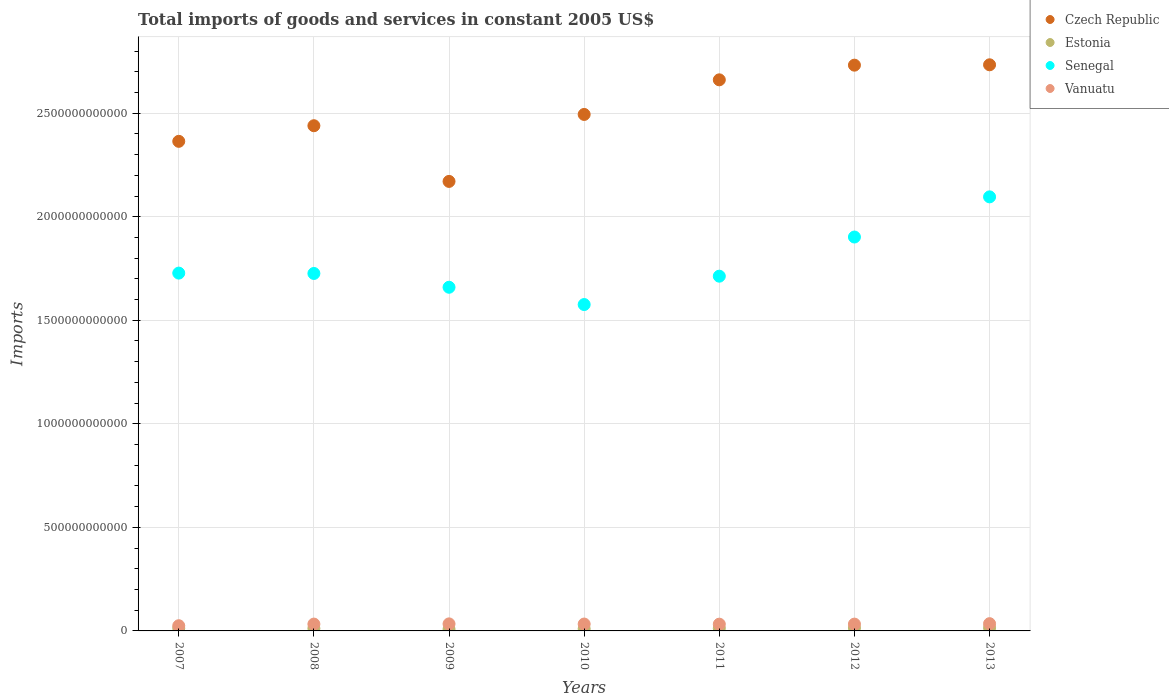How many different coloured dotlines are there?
Your answer should be very brief. 4. Is the number of dotlines equal to the number of legend labels?
Offer a terse response. Yes. What is the total imports of goods and services in Estonia in 2007?
Provide a succinct answer. 1.28e+1. Across all years, what is the maximum total imports of goods and services in Vanuatu?
Your answer should be compact. 3.50e+1. Across all years, what is the minimum total imports of goods and services in Czech Republic?
Keep it short and to the point. 2.17e+12. In which year was the total imports of goods and services in Czech Republic maximum?
Your answer should be very brief. 2013. What is the total total imports of goods and services in Vanuatu in the graph?
Your answer should be very brief. 2.26e+11. What is the difference between the total imports of goods and services in Estonia in 2012 and that in 2013?
Offer a terse response. -6.45e+08. What is the difference between the total imports of goods and services in Vanuatu in 2011 and the total imports of goods and services in Estonia in 2012?
Your answer should be very brief. 1.83e+1. What is the average total imports of goods and services in Czech Republic per year?
Provide a succinct answer. 2.51e+12. In the year 2012, what is the difference between the total imports of goods and services in Senegal and total imports of goods and services in Czech Republic?
Your response must be concise. -8.30e+11. In how many years, is the total imports of goods and services in Czech Republic greater than 100000000000 US$?
Give a very brief answer. 7. What is the ratio of the total imports of goods and services in Estonia in 2007 to that in 2010?
Offer a very short reply. 1.27. Is the total imports of goods and services in Czech Republic in 2007 less than that in 2009?
Your answer should be very brief. No. Is the difference between the total imports of goods and services in Senegal in 2009 and 2013 greater than the difference between the total imports of goods and services in Czech Republic in 2009 and 2013?
Ensure brevity in your answer.  Yes. What is the difference between the highest and the second highest total imports of goods and services in Senegal?
Keep it short and to the point. 1.94e+11. What is the difference between the highest and the lowest total imports of goods and services in Estonia?
Your answer should be compact. 6.67e+09. In how many years, is the total imports of goods and services in Senegal greater than the average total imports of goods and services in Senegal taken over all years?
Offer a terse response. 2. Is it the case that in every year, the sum of the total imports of goods and services in Czech Republic and total imports of goods and services in Senegal  is greater than the total imports of goods and services in Estonia?
Give a very brief answer. Yes. Does the total imports of goods and services in Estonia monotonically increase over the years?
Make the answer very short. No. How many dotlines are there?
Your answer should be compact. 4. How many years are there in the graph?
Give a very brief answer. 7. What is the difference between two consecutive major ticks on the Y-axis?
Provide a succinct answer. 5.00e+11. Does the graph contain any zero values?
Provide a short and direct response. No. Does the graph contain grids?
Provide a short and direct response. Yes. How many legend labels are there?
Provide a short and direct response. 4. What is the title of the graph?
Your response must be concise. Total imports of goods and services in constant 2005 US$. What is the label or title of the X-axis?
Your answer should be compact. Years. What is the label or title of the Y-axis?
Offer a terse response. Imports. What is the Imports of Czech Republic in 2007?
Offer a terse response. 2.36e+12. What is the Imports in Estonia in 2007?
Give a very brief answer. 1.28e+1. What is the Imports in Senegal in 2007?
Provide a succinct answer. 1.73e+12. What is the Imports of Vanuatu in 2007?
Offer a terse response. 2.51e+1. What is the Imports in Czech Republic in 2008?
Your response must be concise. 2.44e+12. What is the Imports in Estonia in 2008?
Ensure brevity in your answer.  1.20e+1. What is the Imports in Senegal in 2008?
Provide a succinct answer. 1.73e+12. What is the Imports in Vanuatu in 2008?
Provide a succinct answer. 3.30e+1. What is the Imports in Czech Republic in 2009?
Offer a very short reply. 2.17e+12. What is the Imports of Estonia in 2009?
Your answer should be very brief. 8.34e+09. What is the Imports of Senegal in 2009?
Give a very brief answer. 1.66e+12. What is the Imports of Vanuatu in 2009?
Your answer should be compact. 3.40e+1. What is the Imports of Czech Republic in 2010?
Give a very brief answer. 2.49e+12. What is the Imports of Estonia in 2010?
Provide a succinct answer. 1.01e+1. What is the Imports of Senegal in 2010?
Give a very brief answer. 1.58e+12. What is the Imports in Vanuatu in 2010?
Make the answer very short. 3.33e+1. What is the Imports in Czech Republic in 2011?
Provide a succinct answer. 2.66e+12. What is the Imports in Estonia in 2011?
Offer a very short reply. 1.29e+1. What is the Imports of Senegal in 2011?
Your answer should be very brief. 1.71e+12. What is the Imports of Vanuatu in 2011?
Provide a short and direct response. 3.26e+1. What is the Imports of Czech Republic in 2012?
Ensure brevity in your answer.  2.73e+12. What is the Imports of Estonia in 2012?
Give a very brief answer. 1.44e+1. What is the Imports in Senegal in 2012?
Keep it short and to the point. 1.90e+12. What is the Imports in Vanuatu in 2012?
Your answer should be compact. 3.29e+1. What is the Imports in Czech Republic in 2013?
Give a very brief answer. 2.73e+12. What is the Imports of Estonia in 2013?
Keep it short and to the point. 1.50e+1. What is the Imports in Senegal in 2013?
Make the answer very short. 2.10e+12. What is the Imports in Vanuatu in 2013?
Offer a terse response. 3.50e+1. Across all years, what is the maximum Imports of Czech Republic?
Give a very brief answer. 2.73e+12. Across all years, what is the maximum Imports of Estonia?
Give a very brief answer. 1.50e+1. Across all years, what is the maximum Imports of Senegal?
Offer a terse response. 2.10e+12. Across all years, what is the maximum Imports of Vanuatu?
Your response must be concise. 3.50e+1. Across all years, what is the minimum Imports in Czech Republic?
Provide a succinct answer. 2.17e+12. Across all years, what is the minimum Imports of Estonia?
Offer a very short reply. 8.34e+09. Across all years, what is the minimum Imports in Senegal?
Ensure brevity in your answer.  1.58e+12. Across all years, what is the minimum Imports of Vanuatu?
Provide a succinct answer. 2.51e+1. What is the total Imports of Czech Republic in the graph?
Your answer should be compact. 1.76e+13. What is the total Imports in Estonia in the graph?
Provide a succinct answer. 8.55e+1. What is the total Imports in Senegal in the graph?
Your answer should be compact. 1.24e+13. What is the total Imports of Vanuatu in the graph?
Your answer should be very brief. 2.26e+11. What is the difference between the Imports in Czech Republic in 2007 and that in 2008?
Give a very brief answer. -7.54e+1. What is the difference between the Imports of Estonia in 2007 and that in 2008?
Give a very brief answer. 7.89e+08. What is the difference between the Imports in Senegal in 2007 and that in 2008?
Offer a terse response. 1.72e+09. What is the difference between the Imports of Vanuatu in 2007 and that in 2008?
Your response must be concise. -7.90e+09. What is the difference between the Imports in Czech Republic in 2007 and that in 2009?
Provide a succinct answer. 1.94e+11. What is the difference between the Imports of Estonia in 2007 and that in 2009?
Your response must be concise. 4.47e+09. What is the difference between the Imports in Senegal in 2007 and that in 2009?
Keep it short and to the point. 6.83e+1. What is the difference between the Imports of Vanuatu in 2007 and that in 2009?
Provide a succinct answer. -8.87e+09. What is the difference between the Imports in Czech Republic in 2007 and that in 2010?
Your answer should be very brief. -1.30e+11. What is the difference between the Imports of Estonia in 2007 and that in 2010?
Offer a terse response. 2.70e+09. What is the difference between the Imports of Senegal in 2007 and that in 2010?
Offer a terse response. 1.52e+11. What is the difference between the Imports of Vanuatu in 2007 and that in 2010?
Offer a very short reply. -8.14e+09. What is the difference between the Imports of Czech Republic in 2007 and that in 2011?
Keep it short and to the point. -2.97e+11. What is the difference between the Imports in Estonia in 2007 and that in 2011?
Give a very brief answer. -5.48e+07. What is the difference between the Imports in Senegal in 2007 and that in 2011?
Ensure brevity in your answer.  1.49e+1. What is the difference between the Imports in Vanuatu in 2007 and that in 2011?
Provide a short and direct response. -7.50e+09. What is the difference between the Imports of Czech Republic in 2007 and that in 2012?
Your answer should be compact. -3.68e+11. What is the difference between the Imports in Estonia in 2007 and that in 2012?
Give a very brief answer. -1.56e+09. What is the difference between the Imports in Senegal in 2007 and that in 2012?
Offer a very short reply. -1.74e+11. What is the difference between the Imports in Vanuatu in 2007 and that in 2012?
Provide a short and direct response. -7.77e+09. What is the difference between the Imports of Czech Republic in 2007 and that in 2013?
Provide a succinct answer. -3.70e+11. What is the difference between the Imports of Estonia in 2007 and that in 2013?
Offer a very short reply. -2.20e+09. What is the difference between the Imports of Senegal in 2007 and that in 2013?
Make the answer very short. -3.68e+11. What is the difference between the Imports of Vanuatu in 2007 and that in 2013?
Keep it short and to the point. -9.89e+09. What is the difference between the Imports in Czech Republic in 2008 and that in 2009?
Make the answer very short. 2.69e+11. What is the difference between the Imports of Estonia in 2008 and that in 2009?
Provide a succinct answer. 3.68e+09. What is the difference between the Imports in Senegal in 2008 and that in 2009?
Give a very brief answer. 6.66e+1. What is the difference between the Imports of Vanuatu in 2008 and that in 2009?
Your response must be concise. -9.74e+08. What is the difference between the Imports of Czech Republic in 2008 and that in 2010?
Give a very brief answer. -5.45e+1. What is the difference between the Imports of Estonia in 2008 and that in 2010?
Your response must be concise. 1.91e+09. What is the difference between the Imports of Senegal in 2008 and that in 2010?
Give a very brief answer. 1.50e+11. What is the difference between the Imports of Vanuatu in 2008 and that in 2010?
Offer a terse response. -2.38e+08. What is the difference between the Imports of Czech Republic in 2008 and that in 2011?
Make the answer very short. -2.22e+11. What is the difference between the Imports in Estonia in 2008 and that in 2011?
Provide a short and direct response. -8.44e+08. What is the difference between the Imports of Senegal in 2008 and that in 2011?
Offer a very short reply. 1.31e+1. What is the difference between the Imports of Vanuatu in 2008 and that in 2011?
Make the answer very short. 4.03e+08. What is the difference between the Imports in Czech Republic in 2008 and that in 2012?
Your response must be concise. -2.92e+11. What is the difference between the Imports in Estonia in 2008 and that in 2012?
Give a very brief answer. -2.35e+09. What is the difference between the Imports in Senegal in 2008 and that in 2012?
Your answer should be compact. -1.76e+11. What is the difference between the Imports in Vanuatu in 2008 and that in 2012?
Keep it short and to the point. 1.32e+08. What is the difference between the Imports in Czech Republic in 2008 and that in 2013?
Your response must be concise. -2.94e+11. What is the difference between the Imports of Estonia in 2008 and that in 2013?
Keep it short and to the point. -2.99e+09. What is the difference between the Imports of Senegal in 2008 and that in 2013?
Your answer should be compact. -3.70e+11. What is the difference between the Imports of Vanuatu in 2008 and that in 2013?
Keep it short and to the point. -1.99e+09. What is the difference between the Imports of Czech Republic in 2009 and that in 2010?
Provide a short and direct response. -3.23e+11. What is the difference between the Imports in Estonia in 2009 and that in 2010?
Offer a very short reply. -1.77e+09. What is the difference between the Imports in Senegal in 2009 and that in 2010?
Your response must be concise. 8.35e+1. What is the difference between the Imports of Vanuatu in 2009 and that in 2010?
Make the answer very short. 7.36e+08. What is the difference between the Imports of Czech Republic in 2009 and that in 2011?
Give a very brief answer. -4.90e+11. What is the difference between the Imports of Estonia in 2009 and that in 2011?
Make the answer very short. -4.52e+09. What is the difference between the Imports in Senegal in 2009 and that in 2011?
Offer a terse response. -5.35e+1. What is the difference between the Imports in Vanuatu in 2009 and that in 2011?
Offer a terse response. 1.38e+09. What is the difference between the Imports of Czech Republic in 2009 and that in 2012?
Ensure brevity in your answer.  -5.61e+11. What is the difference between the Imports in Estonia in 2009 and that in 2012?
Ensure brevity in your answer.  -6.03e+09. What is the difference between the Imports in Senegal in 2009 and that in 2012?
Keep it short and to the point. -2.43e+11. What is the difference between the Imports of Vanuatu in 2009 and that in 2012?
Provide a succinct answer. 1.11e+09. What is the difference between the Imports of Czech Republic in 2009 and that in 2013?
Keep it short and to the point. -5.63e+11. What is the difference between the Imports of Estonia in 2009 and that in 2013?
Your response must be concise. -6.67e+09. What is the difference between the Imports in Senegal in 2009 and that in 2013?
Keep it short and to the point. -4.36e+11. What is the difference between the Imports in Vanuatu in 2009 and that in 2013?
Keep it short and to the point. -1.02e+09. What is the difference between the Imports in Czech Republic in 2010 and that in 2011?
Your answer should be compact. -1.67e+11. What is the difference between the Imports in Estonia in 2010 and that in 2011?
Your response must be concise. -2.75e+09. What is the difference between the Imports of Senegal in 2010 and that in 2011?
Offer a terse response. -1.37e+11. What is the difference between the Imports of Vanuatu in 2010 and that in 2011?
Your answer should be compact. 6.41e+08. What is the difference between the Imports in Czech Republic in 2010 and that in 2012?
Offer a terse response. -2.38e+11. What is the difference between the Imports of Estonia in 2010 and that in 2012?
Provide a succinct answer. -4.26e+09. What is the difference between the Imports in Senegal in 2010 and that in 2012?
Give a very brief answer. -3.26e+11. What is the difference between the Imports of Vanuatu in 2010 and that in 2012?
Ensure brevity in your answer.  3.70e+08. What is the difference between the Imports of Czech Republic in 2010 and that in 2013?
Offer a very short reply. -2.40e+11. What is the difference between the Imports of Estonia in 2010 and that in 2013?
Offer a very short reply. -4.90e+09. What is the difference between the Imports in Senegal in 2010 and that in 2013?
Offer a terse response. -5.20e+11. What is the difference between the Imports in Vanuatu in 2010 and that in 2013?
Provide a succinct answer. -1.75e+09. What is the difference between the Imports of Czech Republic in 2011 and that in 2012?
Your answer should be compact. -7.08e+1. What is the difference between the Imports of Estonia in 2011 and that in 2012?
Your answer should be compact. -1.50e+09. What is the difference between the Imports in Senegal in 2011 and that in 2012?
Provide a succinct answer. -1.89e+11. What is the difference between the Imports in Vanuatu in 2011 and that in 2012?
Your response must be concise. -2.71e+08. What is the difference between the Imports in Czech Republic in 2011 and that in 2013?
Offer a terse response. -7.26e+1. What is the difference between the Imports in Estonia in 2011 and that in 2013?
Provide a short and direct response. -2.15e+09. What is the difference between the Imports in Senegal in 2011 and that in 2013?
Provide a short and direct response. -3.83e+11. What is the difference between the Imports of Vanuatu in 2011 and that in 2013?
Give a very brief answer. -2.40e+09. What is the difference between the Imports in Czech Republic in 2012 and that in 2013?
Your answer should be compact. -1.78e+09. What is the difference between the Imports in Estonia in 2012 and that in 2013?
Your response must be concise. -6.45e+08. What is the difference between the Imports in Senegal in 2012 and that in 2013?
Your answer should be compact. -1.94e+11. What is the difference between the Imports of Vanuatu in 2012 and that in 2013?
Your answer should be compact. -2.12e+09. What is the difference between the Imports of Czech Republic in 2007 and the Imports of Estonia in 2008?
Offer a terse response. 2.35e+12. What is the difference between the Imports of Czech Republic in 2007 and the Imports of Senegal in 2008?
Offer a very short reply. 6.38e+11. What is the difference between the Imports of Czech Republic in 2007 and the Imports of Vanuatu in 2008?
Provide a short and direct response. 2.33e+12. What is the difference between the Imports of Estonia in 2007 and the Imports of Senegal in 2008?
Your answer should be very brief. -1.71e+12. What is the difference between the Imports of Estonia in 2007 and the Imports of Vanuatu in 2008?
Your answer should be compact. -2.02e+1. What is the difference between the Imports in Senegal in 2007 and the Imports in Vanuatu in 2008?
Make the answer very short. 1.69e+12. What is the difference between the Imports in Czech Republic in 2007 and the Imports in Estonia in 2009?
Provide a succinct answer. 2.36e+12. What is the difference between the Imports in Czech Republic in 2007 and the Imports in Senegal in 2009?
Your answer should be very brief. 7.05e+11. What is the difference between the Imports in Czech Republic in 2007 and the Imports in Vanuatu in 2009?
Provide a succinct answer. 2.33e+12. What is the difference between the Imports of Estonia in 2007 and the Imports of Senegal in 2009?
Your answer should be compact. -1.65e+12. What is the difference between the Imports in Estonia in 2007 and the Imports in Vanuatu in 2009?
Offer a very short reply. -2.12e+1. What is the difference between the Imports in Senegal in 2007 and the Imports in Vanuatu in 2009?
Offer a very short reply. 1.69e+12. What is the difference between the Imports in Czech Republic in 2007 and the Imports in Estonia in 2010?
Provide a short and direct response. 2.35e+12. What is the difference between the Imports in Czech Republic in 2007 and the Imports in Senegal in 2010?
Give a very brief answer. 7.88e+11. What is the difference between the Imports in Czech Republic in 2007 and the Imports in Vanuatu in 2010?
Provide a short and direct response. 2.33e+12. What is the difference between the Imports in Estonia in 2007 and the Imports in Senegal in 2010?
Your response must be concise. -1.56e+12. What is the difference between the Imports of Estonia in 2007 and the Imports of Vanuatu in 2010?
Ensure brevity in your answer.  -2.05e+1. What is the difference between the Imports of Senegal in 2007 and the Imports of Vanuatu in 2010?
Keep it short and to the point. 1.69e+12. What is the difference between the Imports in Czech Republic in 2007 and the Imports in Estonia in 2011?
Keep it short and to the point. 2.35e+12. What is the difference between the Imports of Czech Republic in 2007 and the Imports of Senegal in 2011?
Your response must be concise. 6.51e+11. What is the difference between the Imports in Czech Republic in 2007 and the Imports in Vanuatu in 2011?
Give a very brief answer. 2.33e+12. What is the difference between the Imports in Estonia in 2007 and the Imports in Senegal in 2011?
Offer a very short reply. -1.70e+12. What is the difference between the Imports in Estonia in 2007 and the Imports in Vanuatu in 2011?
Ensure brevity in your answer.  -1.98e+1. What is the difference between the Imports of Senegal in 2007 and the Imports of Vanuatu in 2011?
Ensure brevity in your answer.  1.70e+12. What is the difference between the Imports in Czech Republic in 2007 and the Imports in Estonia in 2012?
Provide a succinct answer. 2.35e+12. What is the difference between the Imports in Czech Republic in 2007 and the Imports in Senegal in 2012?
Your answer should be compact. 4.62e+11. What is the difference between the Imports of Czech Republic in 2007 and the Imports of Vanuatu in 2012?
Make the answer very short. 2.33e+12. What is the difference between the Imports of Estonia in 2007 and the Imports of Senegal in 2012?
Give a very brief answer. -1.89e+12. What is the difference between the Imports of Estonia in 2007 and the Imports of Vanuatu in 2012?
Provide a succinct answer. -2.01e+1. What is the difference between the Imports of Senegal in 2007 and the Imports of Vanuatu in 2012?
Offer a very short reply. 1.69e+12. What is the difference between the Imports of Czech Republic in 2007 and the Imports of Estonia in 2013?
Offer a very short reply. 2.35e+12. What is the difference between the Imports of Czech Republic in 2007 and the Imports of Senegal in 2013?
Your response must be concise. 2.68e+11. What is the difference between the Imports of Czech Republic in 2007 and the Imports of Vanuatu in 2013?
Offer a very short reply. 2.33e+12. What is the difference between the Imports in Estonia in 2007 and the Imports in Senegal in 2013?
Ensure brevity in your answer.  -2.08e+12. What is the difference between the Imports of Estonia in 2007 and the Imports of Vanuatu in 2013?
Provide a short and direct response. -2.22e+1. What is the difference between the Imports of Senegal in 2007 and the Imports of Vanuatu in 2013?
Offer a very short reply. 1.69e+12. What is the difference between the Imports in Czech Republic in 2008 and the Imports in Estonia in 2009?
Your response must be concise. 2.43e+12. What is the difference between the Imports in Czech Republic in 2008 and the Imports in Senegal in 2009?
Offer a very short reply. 7.80e+11. What is the difference between the Imports in Czech Republic in 2008 and the Imports in Vanuatu in 2009?
Offer a terse response. 2.41e+12. What is the difference between the Imports of Estonia in 2008 and the Imports of Senegal in 2009?
Give a very brief answer. -1.65e+12. What is the difference between the Imports of Estonia in 2008 and the Imports of Vanuatu in 2009?
Make the answer very short. -2.20e+1. What is the difference between the Imports of Senegal in 2008 and the Imports of Vanuatu in 2009?
Your answer should be compact. 1.69e+12. What is the difference between the Imports of Czech Republic in 2008 and the Imports of Estonia in 2010?
Your answer should be very brief. 2.43e+12. What is the difference between the Imports in Czech Republic in 2008 and the Imports in Senegal in 2010?
Your response must be concise. 8.63e+11. What is the difference between the Imports in Czech Republic in 2008 and the Imports in Vanuatu in 2010?
Your answer should be compact. 2.41e+12. What is the difference between the Imports of Estonia in 2008 and the Imports of Senegal in 2010?
Make the answer very short. -1.56e+12. What is the difference between the Imports of Estonia in 2008 and the Imports of Vanuatu in 2010?
Make the answer very short. -2.12e+1. What is the difference between the Imports of Senegal in 2008 and the Imports of Vanuatu in 2010?
Provide a short and direct response. 1.69e+12. What is the difference between the Imports of Czech Republic in 2008 and the Imports of Estonia in 2011?
Your answer should be compact. 2.43e+12. What is the difference between the Imports of Czech Republic in 2008 and the Imports of Senegal in 2011?
Provide a succinct answer. 7.27e+11. What is the difference between the Imports in Czech Republic in 2008 and the Imports in Vanuatu in 2011?
Make the answer very short. 2.41e+12. What is the difference between the Imports of Estonia in 2008 and the Imports of Senegal in 2011?
Your response must be concise. -1.70e+12. What is the difference between the Imports of Estonia in 2008 and the Imports of Vanuatu in 2011?
Make the answer very short. -2.06e+1. What is the difference between the Imports of Senegal in 2008 and the Imports of Vanuatu in 2011?
Your answer should be very brief. 1.69e+12. What is the difference between the Imports in Czech Republic in 2008 and the Imports in Estonia in 2012?
Provide a succinct answer. 2.43e+12. What is the difference between the Imports of Czech Republic in 2008 and the Imports of Senegal in 2012?
Offer a terse response. 5.37e+11. What is the difference between the Imports of Czech Republic in 2008 and the Imports of Vanuatu in 2012?
Give a very brief answer. 2.41e+12. What is the difference between the Imports in Estonia in 2008 and the Imports in Senegal in 2012?
Keep it short and to the point. -1.89e+12. What is the difference between the Imports of Estonia in 2008 and the Imports of Vanuatu in 2012?
Provide a short and direct response. -2.09e+1. What is the difference between the Imports of Senegal in 2008 and the Imports of Vanuatu in 2012?
Ensure brevity in your answer.  1.69e+12. What is the difference between the Imports in Czech Republic in 2008 and the Imports in Estonia in 2013?
Keep it short and to the point. 2.42e+12. What is the difference between the Imports of Czech Republic in 2008 and the Imports of Senegal in 2013?
Offer a very short reply. 3.44e+11. What is the difference between the Imports in Czech Republic in 2008 and the Imports in Vanuatu in 2013?
Offer a very short reply. 2.40e+12. What is the difference between the Imports in Estonia in 2008 and the Imports in Senegal in 2013?
Ensure brevity in your answer.  -2.08e+12. What is the difference between the Imports in Estonia in 2008 and the Imports in Vanuatu in 2013?
Offer a very short reply. -2.30e+1. What is the difference between the Imports of Senegal in 2008 and the Imports of Vanuatu in 2013?
Ensure brevity in your answer.  1.69e+12. What is the difference between the Imports in Czech Republic in 2009 and the Imports in Estonia in 2010?
Your response must be concise. 2.16e+12. What is the difference between the Imports of Czech Republic in 2009 and the Imports of Senegal in 2010?
Your response must be concise. 5.95e+11. What is the difference between the Imports of Czech Republic in 2009 and the Imports of Vanuatu in 2010?
Your answer should be compact. 2.14e+12. What is the difference between the Imports in Estonia in 2009 and the Imports in Senegal in 2010?
Provide a short and direct response. -1.57e+12. What is the difference between the Imports in Estonia in 2009 and the Imports in Vanuatu in 2010?
Ensure brevity in your answer.  -2.49e+1. What is the difference between the Imports of Senegal in 2009 and the Imports of Vanuatu in 2010?
Provide a succinct answer. 1.63e+12. What is the difference between the Imports of Czech Republic in 2009 and the Imports of Estonia in 2011?
Your response must be concise. 2.16e+12. What is the difference between the Imports of Czech Republic in 2009 and the Imports of Senegal in 2011?
Your answer should be compact. 4.58e+11. What is the difference between the Imports in Czech Republic in 2009 and the Imports in Vanuatu in 2011?
Offer a very short reply. 2.14e+12. What is the difference between the Imports of Estonia in 2009 and the Imports of Senegal in 2011?
Your answer should be very brief. -1.70e+12. What is the difference between the Imports of Estonia in 2009 and the Imports of Vanuatu in 2011?
Provide a succinct answer. -2.43e+1. What is the difference between the Imports of Senegal in 2009 and the Imports of Vanuatu in 2011?
Your response must be concise. 1.63e+12. What is the difference between the Imports in Czech Republic in 2009 and the Imports in Estonia in 2012?
Ensure brevity in your answer.  2.16e+12. What is the difference between the Imports in Czech Republic in 2009 and the Imports in Senegal in 2012?
Your answer should be compact. 2.69e+11. What is the difference between the Imports of Czech Republic in 2009 and the Imports of Vanuatu in 2012?
Ensure brevity in your answer.  2.14e+12. What is the difference between the Imports of Estonia in 2009 and the Imports of Senegal in 2012?
Your response must be concise. -1.89e+12. What is the difference between the Imports of Estonia in 2009 and the Imports of Vanuatu in 2012?
Offer a terse response. -2.46e+1. What is the difference between the Imports in Senegal in 2009 and the Imports in Vanuatu in 2012?
Offer a terse response. 1.63e+12. What is the difference between the Imports of Czech Republic in 2009 and the Imports of Estonia in 2013?
Your answer should be very brief. 2.16e+12. What is the difference between the Imports in Czech Republic in 2009 and the Imports in Senegal in 2013?
Keep it short and to the point. 7.46e+1. What is the difference between the Imports of Czech Republic in 2009 and the Imports of Vanuatu in 2013?
Provide a succinct answer. 2.14e+12. What is the difference between the Imports in Estonia in 2009 and the Imports in Senegal in 2013?
Keep it short and to the point. -2.09e+12. What is the difference between the Imports of Estonia in 2009 and the Imports of Vanuatu in 2013?
Make the answer very short. -2.67e+1. What is the difference between the Imports of Senegal in 2009 and the Imports of Vanuatu in 2013?
Your response must be concise. 1.62e+12. What is the difference between the Imports of Czech Republic in 2010 and the Imports of Estonia in 2011?
Your answer should be very brief. 2.48e+12. What is the difference between the Imports of Czech Republic in 2010 and the Imports of Senegal in 2011?
Provide a succinct answer. 7.81e+11. What is the difference between the Imports of Czech Republic in 2010 and the Imports of Vanuatu in 2011?
Provide a short and direct response. 2.46e+12. What is the difference between the Imports of Estonia in 2010 and the Imports of Senegal in 2011?
Provide a short and direct response. -1.70e+12. What is the difference between the Imports in Estonia in 2010 and the Imports in Vanuatu in 2011?
Your answer should be very brief. -2.25e+1. What is the difference between the Imports in Senegal in 2010 and the Imports in Vanuatu in 2011?
Offer a very short reply. 1.54e+12. What is the difference between the Imports in Czech Republic in 2010 and the Imports in Estonia in 2012?
Make the answer very short. 2.48e+12. What is the difference between the Imports in Czech Republic in 2010 and the Imports in Senegal in 2012?
Offer a very short reply. 5.92e+11. What is the difference between the Imports in Czech Republic in 2010 and the Imports in Vanuatu in 2012?
Ensure brevity in your answer.  2.46e+12. What is the difference between the Imports of Estonia in 2010 and the Imports of Senegal in 2012?
Keep it short and to the point. -1.89e+12. What is the difference between the Imports in Estonia in 2010 and the Imports in Vanuatu in 2012?
Provide a succinct answer. -2.28e+1. What is the difference between the Imports in Senegal in 2010 and the Imports in Vanuatu in 2012?
Offer a very short reply. 1.54e+12. What is the difference between the Imports of Czech Republic in 2010 and the Imports of Estonia in 2013?
Keep it short and to the point. 2.48e+12. What is the difference between the Imports in Czech Republic in 2010 and the Imports in Senegal in 2013?
Offer a very short reply. 3.98e+11. What is the difference between the Imports of Czech Republic in 2010 and the Imports of Vanuatu in 2013?
Your response must be concise. 2.46e+12. What is the difference between the Imports of Estonia in 2010 and the Imports of Senegal in 2013?
Keep it short and to the point. -2.09e+12. What is the difference between the Imports of Estonia in 2010 and the Imports of Vanuatu in 2013?
Provide a succinct answer. -2.49e+1. What is the difference between the Imports in Senegal in 2010 and the Imports in Vanuatu in 2013?
Provide a succinct answer. 1.54e+12. What is the difference between the Imports of Czech Republic in 2011 and the Imports of Estonia in 2012?
Your answer should be compact. 2.65e+12. What is the difference between the Imports of Czech Republic in 2011 and the Imports of Senegal in 2012?
Your answer should be compact. 7.59e+11. What is the difference between the Imports of Czech Republic in 2011 and the Imports of Vanuatu in 2012?
Provide a short and direct response. 2.63e+12. What is the difference between the Imports of Estonia in 2011 and the Imports of Senegal in 2012?
Make the answer very short. -1.89e+12. What is the difference between the Imports of Estonia in 2011 and the Imports of Vanuatu in 2012?
Offer a very short reply. -2.00e+1. What is the difference between the Imports of Senegal in 2011 and the Imports of Vanuatu in 2012?
Your answer should be compact. 1.68e+12. What is the difference between the Imports in Czech Republic in 2011 and the Imports in Estonia in 2013?
Offer a very short reply. 2.65e+12. What is the difference between the Imports of Czech Republic in 2011 and the Imports of Senegal in 2013?
Provide a succinct answer. 5.65e+11. What is the difference between the Imports of Czech Republic in 2011 and the Imports of Vanuatu in 2013?
Keep it short and to the point. 2.63e+12. What is the difference between the Imports of Estonia in 2011 and the Imports of Senegal in 2013?
Give a very brief answer. -2.08e+12. What is the difference between the Imports in Estonia in 2011 and the Imports in Vanuatu in 2013?
Your answer should be compact. -2.22e+1. What is the difference between the Imports of Senegal in 2011 and the Imports of Vanuatu in 2013?
Your response must be concise. 1.68e+12. What is the difference between the Imports in Czech Republic in 2012 and the Imports in Estonia in 2013?
Your answer should be very brief. 2.72e+12. What is the difference between the Imports in Czech Republic in 2012 and the Imports in Senegal in 2013?
Your answer should be compact. 6.36e+11. What is the difference between the Imports of Czech Republic in 2012 and the Imports of Vanuatu in 2013?
Ensure brevity in your answer.  2.70e+12. What is the difference between the Imports in Estonia in 2012 and the Imports in Senegal in 2013?
Provide a short and direct response. -2.08e+12. What is the difference between the Imports in Estonia in 2012 and the Imports in Vanuatu in 2013?
Offer a very short reply. -2.06e+1. What is the difference between the Imports of Senegal in 2012 and the Imports of Vanuatu in 2013?
Offer a very short reply. 1.87e+12. What is the average Imports of Czech Republic per year?
Offer a terse response. 2.51e+12. What is the average Imports of Estonia per year?
Provide a succinct answer. 1.22e+1. What is the average Imports in Senegal per year?
Provide a short and direct response. 1.77e+12. What is the average Imports of Vanuatu per year?
Provide a succinct answer. 3.23e+1. In the year 2007, what is the difference between the Imports in Czech Republic and Imports in Estonia?
Your answer should be very brief. 2.35e+12. In the year 2007, what is the difference between the Imports of Czech Republic and Imports of Senegal?
Provide a succinct answer. 6.36e+11. In the year 2007, what is the difference between the Imports of Czech Republic and Imports of Vanuatu?
Your answer should be very brief. 2.34e+12. In the year 2007, what is the difference between the Imports in Estonia and Imports in Senegal?
Offer a very short reply. -1.71e+12. In the year 2007, what is the difference between the Imports in Estonia and Imports in Vanuatu?
Your response must be concise. -1.23e+1. In the year 2007, what is the difference between the Imports of Senegal and Imports of Vanuatu?
Your answer should be compact. 1.70e+12. In the year 2008, what is the difference between the Imports in Czech Republic and Imports in Estonia?
Keep it short and to the point. 2.43e+12. In the year 2008, what is the difference between the Imports of Czech Republic and Imports of Senegal?
Offer a very short reply. 7.13e+11. In the year 2008, what is the difference between the Imports of Czech Republic and Imports of Vanuatu?
Ensure brevity in your answer.  2.41e+12. In the year 2008, what is the difference between the Imports of Estonia and Imports of Senegal?
Offer a terse response. -1.71e+12. In the year 2008, what is the difference between the Imports of Estonia and Imports of Vanuatu?
Offer a terse response. -2.10e+1. In the year 2008, what is the difference between the Imports in Senegal and Imports in Vanuatu?
Your answer should be compact. 1.69e+12. In the year 2009, what is the difference between the Imports of Czech Republic and Imports of Estonia?
Provide a succinct answer. 2.16e+12. In the year 2009, what is the difference between the Imports in Czech Republic and Imports in Senegal?
Provide a succinct answer. 5.11e+11. In the year 2009, what is the difference between the Imports of Czech Republic and Imports of Vanuatu?
Offer a very short reply. 2.14e+12. In the year 2009, what is the difference between the Imports in Estonia and Imports in Senegal?
Your answer should be compact. -1.65e+12. In the year 2009, what is the difference between the Imports in Estonia and Imports in Vanuatu?
Your answer should be very brief. -2.57e+1. In the year 2009, what is the difference between the Imports of Senegal and Imports of Vanuatu?
Give a very brief answer. 1.63e+12. In the year 2010, what is the difference between the Imports in Czech Republic and Imports in Estonia?
Your answer should be very brief. 2.48e+12. In the year 2010, what is the difference between the Imports of Czech Republic and Imports of Senegal?
Offer a terse response. 9.18e+11. In the year 2010, what is the difference between the Imports of Czech Republic and Imports of Vanuatu?
Offer a very short reply. 2.46e+12. In the year 2010, what is the difference between the Imports in Estonia and Imports in Senegal?
Make the answer very short. -1.57e+12. In the year 2010, what is the difference between the Imports of Estonia and Imports of Vanuatu?
Your answer should be compact. -2.32e+1. In the year 2010, what is the difference between the Imports of Senegal and Imports of Vanuatu?
Provide a short and direct response. 1.54e+12. In the year 2011, what is the difference between the Imports in Czech Republic and Imports in Estonia?
Ensure brevity in your answer.  2.65e+12. In the year 2011, what is the difference between the Imports in Czech Republic and Imports in Senegal?
Keep it short and to the point. 9.48e+11. In the year 2011, what is the difference between the Imports in Czech Republic and Imports in Vanuatu?
Give a very brief answer. 2.63e+12. In the year 2011, what is the difference between the Imports in Estonia and Imports in Senegal?
Offer a terse response. -1.70e+12. In the year 2011, what is the difference between the Imports in Estonia and Imports in Vanuatu?
Keep it short and to the point. -1.98e+1. In the year 2011, what is the difference between the Imports of Senegal and Imports of Vanuatu?
Make the answer very short. 1.68e+12. In the year 2012, what is the difference between the Imports of Czech Republic and Imports of Estonia?
Give a very brief answer. 2.72e+12. In the year 2012, what is the difference between the Imports of Czech Republic and Imports of Senegal?
Your answer should be compact. 8.30e+11. In the year 2012, what is the difference between the Imports of Czech Republic and Imports of Vanuatu?
Give a very brief answer. 2.70e+12. In the year 2012, what is the difference between the Imports in Estonia and Imports in Senegal?
Provide a succinct answer. -1.89e+12. In the year 2012, what is the difference between the Imports in Estonia and Imports in Vanuatu?
Provide a succinct answer. -1.85e+1. In the year 2012, what is the difference between the Imports in Senegal and Imports in Vanuatu?
Offer a terse response. 1.87e+12. In the year 2013, what is the difference between the Imports in Czech Republic and Imports in Estonia?
Keep it short and to the point. 2.72e+12. In the year 2013, what is the difference between the Imports of Czech Republic and Imports of Senegal?
Your answer should be compact. 6.38e+11. In the year 2013, what is the difference between the Imports in Czech Republic and Imports in Vanuatu?
Ensure brevity in your answer.  2.70e+12. In the year 2013, what is the difference between the Imports in Estonia and Imports in Senegal?
Keep it short and to the point. -2.08e+12. In the year 2013, what is the difference between the Imports of Estonia and Imports of Vanuatu?
Ensure brevity in your answer.  -2.00e+1. In the year 2013, what is the difference between the Imports of Senegal and Imports of Vanuatu?
Offer a terse response. 2.06e+12. What is the ratio of the Imports of Czech Republic in 2007 to that in 2008?
Give a very brief answer. 0.97. What is the ratio of the Imports of Estonia in 2007 to that in 2008?
Provide a short and direct response. 1.07. What is the ratio of the Imports in Vanuatu in 2007 to that in 2008?
Make the answer very short. 0.76. What is the ratio of the Imports of Czech Republic in 2007 to that in 2009?
Provide a short and direct response. 1.09. What is the ratio of the Imports in Estonia in 2007 to that in 2009?
Keep it short and to the point. 1.54. What is the ratio of the Imports of Senegal in 2007 to that in 2009?
Your answer should be compact. 1.04. What is the ratio of the Imports in Vanuatu in 2007 to that in 2009?
Your response must be concise. 0.74. What is the ratio of the Imports in Czech Republic in 2007 to that in 2010?
Provide a short and direct response. 0.95. What is the ratio of the Imports in Estonia in 2007 to that in 2010?
Provide a succinct answer. 1.27. What is the ratio of the Imports in Senegal in 2007 to that in 2010?
Offer a terse response. 1.1. What is the ratio of the Imports of Vanuatu in 2007 to that in 2010?
Keep it short and to the point. 0.76. What is the ratio of the Imports in Czech Republic in 2007 to that in 2011?
Give a very brief answer. 0.89. What is the ratio of the Imports of Estonia in 2007 to that in 2011?
Offer a very short reply. 1. What is the ratio of the Imports in Senegal in 2007 to that in 2011?
Give a very brief answer. 1.01. What is the ratio of the Imports of Vanuatu in 2007 to that in 2011?
Make the answer very short. 0.77. What is the ratio of the Imports of Czech Republic in 2007 to that in 2012?
Give a very brief answer. 0.87. What is the ratio of the Imports of Estonia in 2007 to that in 2012?
Ensure brevity in your answer.  0.89. What is the ratio of the Imports in Senegal in 2007 to that in 2012?
Your response must be concise. 0.91. What is the ratio of the Imports in Vanuatu in 2007 to that in 2012?
Keep it short and to the point. 0.76. What is the ratio of the Imports of Czech Republic in 2007 to that in 2013?
Offer a terse response. 0.86. What is the ratio of the Imports of Estonia in 2007 to that in 2013?
Your answer should be very brief. 0.85. What is the ratio of the Imports in Senegal in 2007 to that in 2013?
Offer a very short reply. 0.82. What is the ratio of the Imports in Vanuatu in 2007 to that in 2013?
Your answer should be compact. 0.72. What is the ratio of the Imports in Czech Republic in 2008 to that in 2009?
Offer a very short reply. 1.12. What is the ratio of the Imports of Estonia in 2008 to that in 2009?
Offer a terse response. 1.44. What is the ratio of the Imports of Senegal in 2008 to that in 2009?
Provide a short and direct response. 1.04. What is the ratio of the Imports of Vanuatu in 2008 to that in 2009?
Keep it short and to the point. 0.97. What is the ratio of the Imports in Czech Republic in 2008 to that in 2010?
Make the answer very short. 0.98. What is the ratio of the Imports of Estonia in 2008 to that in 2010?
Your answer should be compact. 1.19. What is the ratio of the Imports of Senegal in 2008 to that in 2010?
Give a very brief answer. 1.1. What is the ratio of the Imports in Vanuatu in 2008 to that in 2010?
Keep it short and to the point. 0.99. What is the ratio of the Imports in Estonia in 2008 to that in 2011?
Keep it short and to the point. 0.93. What is the ratio of the Imports in Senegal in 2008 to that in 2011?
Provide a short and direct response. 1.01. What is the ratio of the Imports of Vanuatu in 2008 to that in 2011?
Keep it short and to the point. 1.01. What is the ratio of the Imports of Czech Republic in 2008 to that in 2012?
Make the answer very short. 0.89. What is the ratio of the Imports in Estonia in 2008 to that in 2012?
Keep it short and to the point. 0.84. What is the ratio of the Imports in Senegal in 2008 to that in 2012?
Provide a short and direct response. 0.91. What is the ratio of the Imports of Czech Republic in 2008 to that in 2013?
Make the answer very short. 0.89. What is the ratio of the Imports of Estonia in 2008 to that in 2013?
Offer a terse response. 0.8. What is the ratio of the Imports of Senegal in 2008 to that in 2013?
Make the answer very short. 0.82. What is the ratio of the Imports in Vanuatu in 2008 to that in 2013?
Provide a succinct answer. 0.94. What is the ratio of the Imports in Czech Republic in 2009 to that in 2010?
Your answer should be compact. 0.87. What is the ratio of the Imports in Estonia in 2009 to that in 2010?
Your response must be concise. 0.82. What is the ratio of the Imports of Senegal in 2009 to that in 2010?
Your answer should be compact. 1.05. What is the ratio of the Imports of Vanuatu in 2009 to that in 2010?
Provide a succinct answer. 1.02. What is the ratio of the Imports in Czech Republic in 2009 to that in 2011?
Give a very brief answer. 0.82. What is the ratio of the Imports in Estonia in 2009 to that in 2011?
Your response must be concise. 0.65. What is the ratio of the Imports of Senegal in 2009 to that in 2011?
Your answer should be compact. 0.97. What is the ratio of the Imports of Vanuatu in 2009 to that in 2011?
Keep it short and to the point. 1.04. What is the ratio of the Imports of Czech Republic in 2009 to that in 2012?
Provide a succinct answer. 0.79. What is the ratio of the Imports of Estonia in 2009 to that in 2012?
Offer a terse response. 0.58. What is the ratio of the Imports in Senegal in 2009 to that in 2012?
Make the answer very short. 0.87. What is the ratio of the Imports in Vanuatu in 2009 to that in 2012?
Your answer should be very brief. 1.03. What is the ratio of the Imports in Czech Republic in 2009 to that in 2013?
Provide a succinct answer. 0.79. What is the ratio of the Imports of Estonia in 2009 to that in 2013?
Offer a very short reply. 0.56. What is the ratio of the Imports of Senegal in 2009 to that in 2013?
Provide a short and direct response. 0.79. What is the ratio of the Imports of Vanuatu in 2009 to that in 2013?
Make the answer very short. 0.97. What is the ratio of the Imports of Czech Republic in 2010 to that in 2011?
Make the answer very short. 0.94. What is the ratio of the Imports of Estonia in 2010 to that in 2011?
Provide a succinct answer. 0.79. What is the ratio of the Imports of Senegal in 2010 to that in 2011?
Give a very brief answer. 0.92. What is the ratio of the Imports of Vanuatu in 2010 to that in 2011?
Provide a short and direct response. 1.02. What is the ratio of the Imports of Czech Republic in 2010 to that in 2012?
Your answer should be very brief. 0.91. What is the ratio of the Imports of Estonia in 2010 to that in 2012?
Offer a terse response. 0.7. What is the ratio of the Imports of Senegal in 2010 to that in 2012?
Your answer should be very brief. 0.83. What is the ratio of the Imports of Vanuatu in 2010 to that in 2012?
Give a very brief answer. 1.01. What is the ratio of the Imports of Czech Republic in 2010 to that in 2013?
Offer a terse response. 0.91. What is the ratio of the Imports of Estonia in 2010 to that in 2013?
Your answer should be compact. 0.67. What is the ratio of the Imports in Senegal in 2010 to that in 2013?
Your answer should be very brief. 0.75. What is the ratio of the Imports of Vanuatu in 2010 to that in 2013?
Ensure brevity in your answer.  0.95. What is the ratio of the Imports in Czech Republic in 2011 to that in 2012?
Your answer should be compact. 0.97. What is the ratio of the Imports in Estonia in 2011 to that in 2012?
Your response must be concise. 0.9. What is the ratio of the Imports in Senegal in 2011 to that in 2012?
Your answer should be compact. 0.9. What is the ratio of the Imports in Czech Republic in 2011 to that in 2013?
Give a very brief answer. 0.97. What is the ratio of the Imports of Estonia in 2011 to that in 2013?
Your answer should be very brief. 0.86. What is the ratio of the Imports in Senegal in 2011 to that in 2013?
Your answer should be compact. 0.82. What is the ratio of the Imports of Vanuatu in 2011 to that in 2013?
Make the answer very short. 0.93. What is the ratio of the Imports in Czech Republic in 2012 to that in 2013?
Ensure brevity in your answer.  1. What is the ratio of the Imports of Estonia in 2012 to that in 2013?
Offer a terse response. 0.96. What is the ratio of the Imports in Senegal in 2012 to that in 2013?
Make the answer very short. 0.91. What is the ratio of the Imports in Vanuatu in 2012 to that in 2013?
Provide a short and direct response. 0.94. What is the difference between the highest and the second highest Imports of Czech Republic?
Provide a short and direct response. 1.78e+09. What is the difference between the highest and the second highest Imports in Estonia?
Your response must be concise. 6.45e+08. What is the difference between the highest and the second highest Imports of Senegal?
Your answer should be very brief. 1.94e+11. What is the difference between the highest and the second highest Imports of Vanuatu?
Your response must be concise. 1.02e+09. What is the difference between the highest and the lowest Imports of Czech Republic?
Your answer should be very brief. 5.63e+11. What is the difference between the highest and the lowest Imports of Estonia?
Your answer should be very brief. 6.67e+09. What is the difference between the highest and the lowest Imports of Senegal?
Give a very brief answer. 5.20e+11. What is the difference between the highest and the lowest Imports of Vanuatu?
Give a very brief answer. 9.89e+09. 